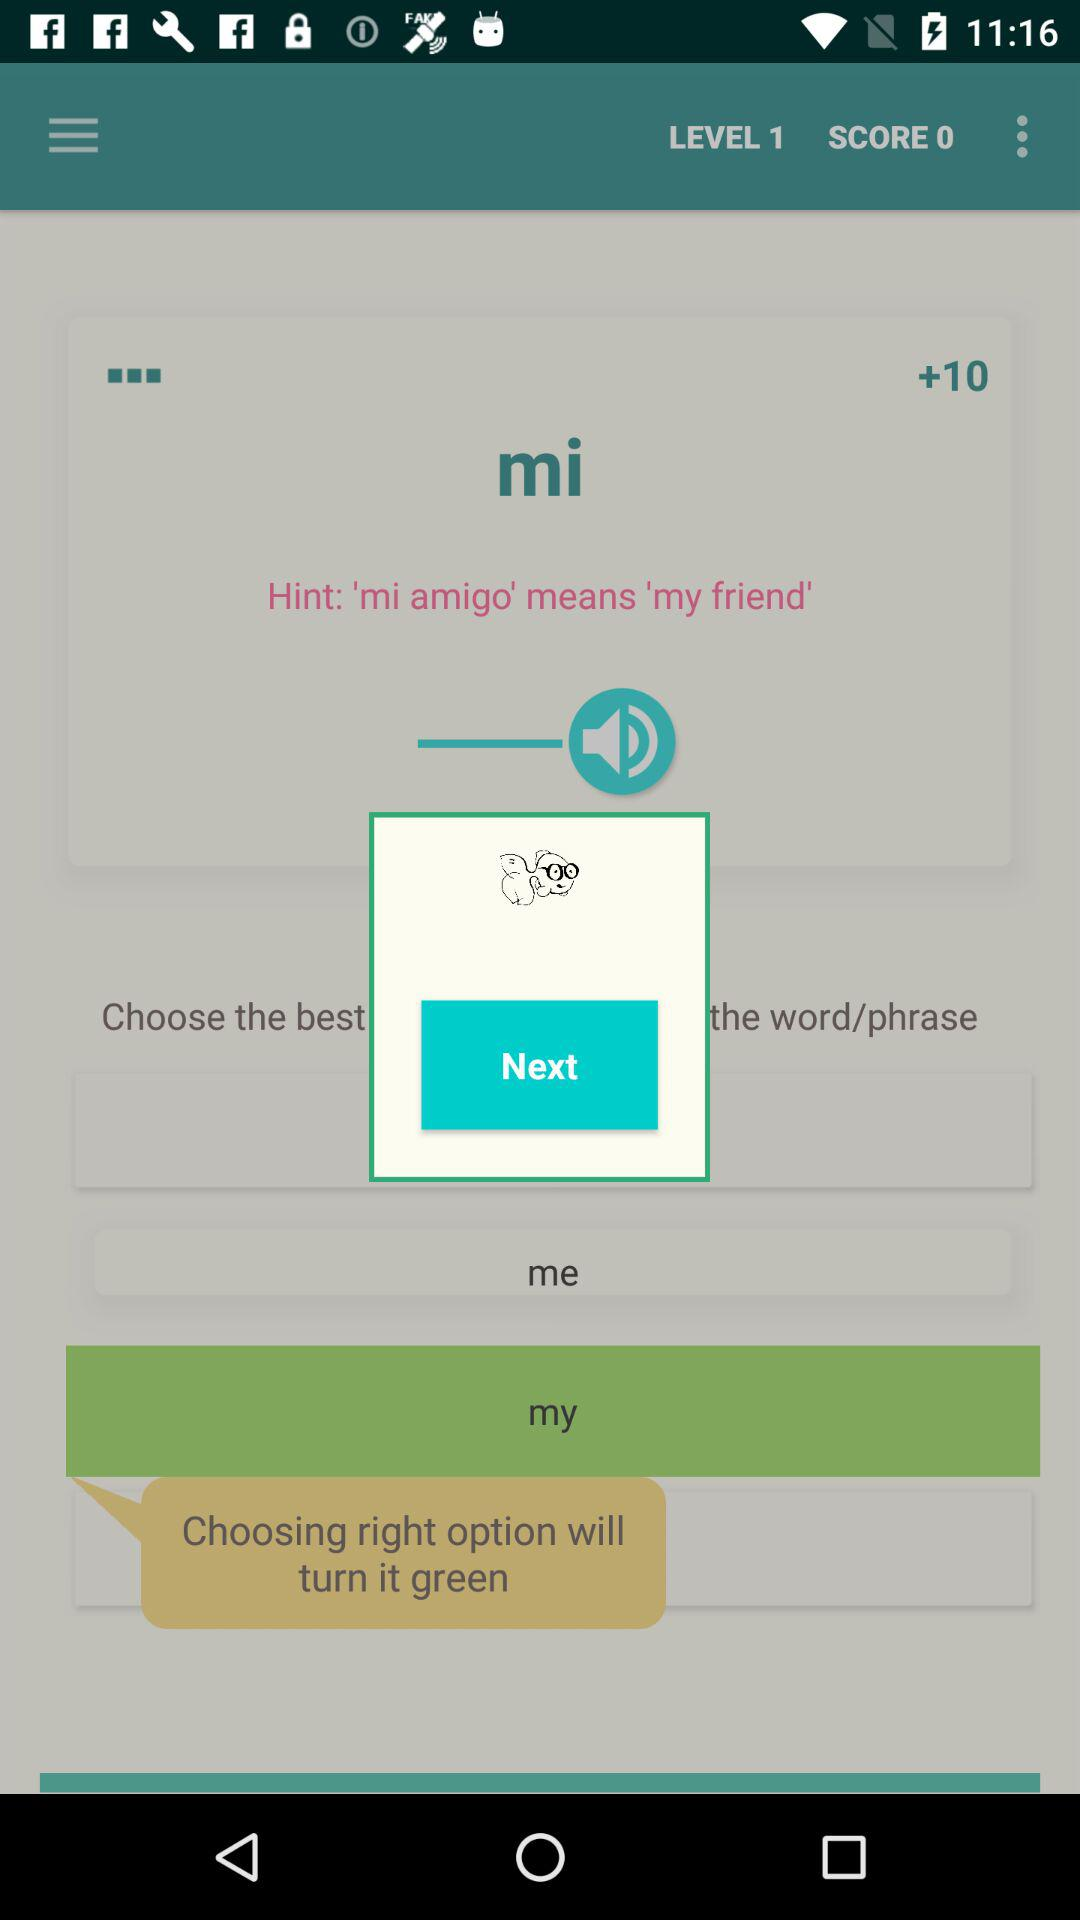How many more points do I have than I started with?
Answer the question using a single word or phrase. 10 